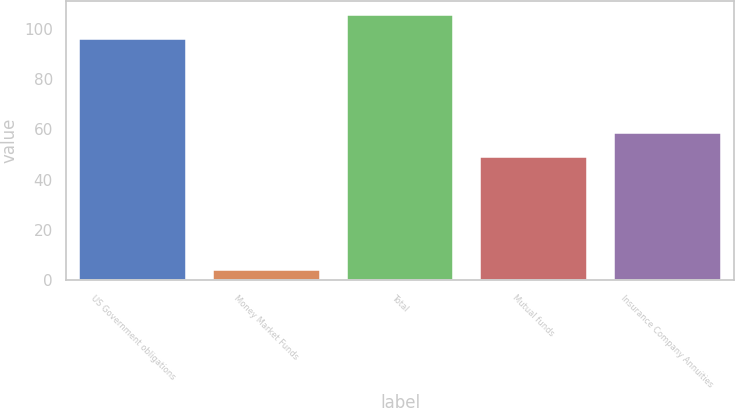Convert chart to OTSL. <chart><loc_0><loc_0><loc_500><loc_500><bar_chart><fcel>US Government obligations<fcel>Money Market Funds<fcel>Total<fcel>Mutual funds<fcel>Insurance Company Annuities<nl><fcel>96<fcel>4<fcel>105.6<fcel>49<fcel>58.6<nl></chart> 